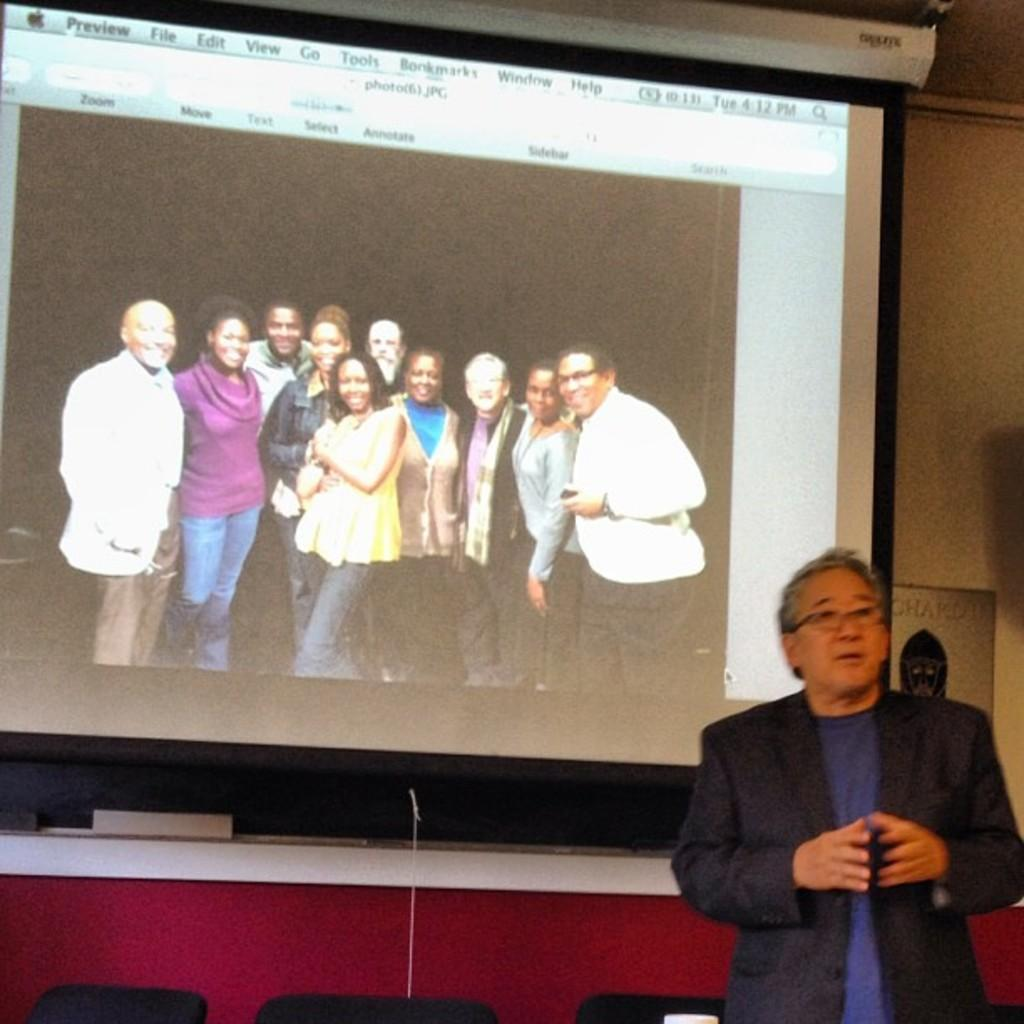What is located on the right side of the image? There is a man standing on the right side of the image. What is the man wearing in the image? The man is wearing a coat and a t-shirt. What can be seen in the middle of the image? There is a projected image in the middle of the image. What is happening in the projected image? In the projected image, there is a group of people standing, and they are smiling. What type of lift is being used by the man in the image? There is no lift present in the image; the man is simply standing on the right side. What meal is being prepared by the people in the projected image? There is no meal preparation happening in the image; the people in the projected image are just standing and smiling. 